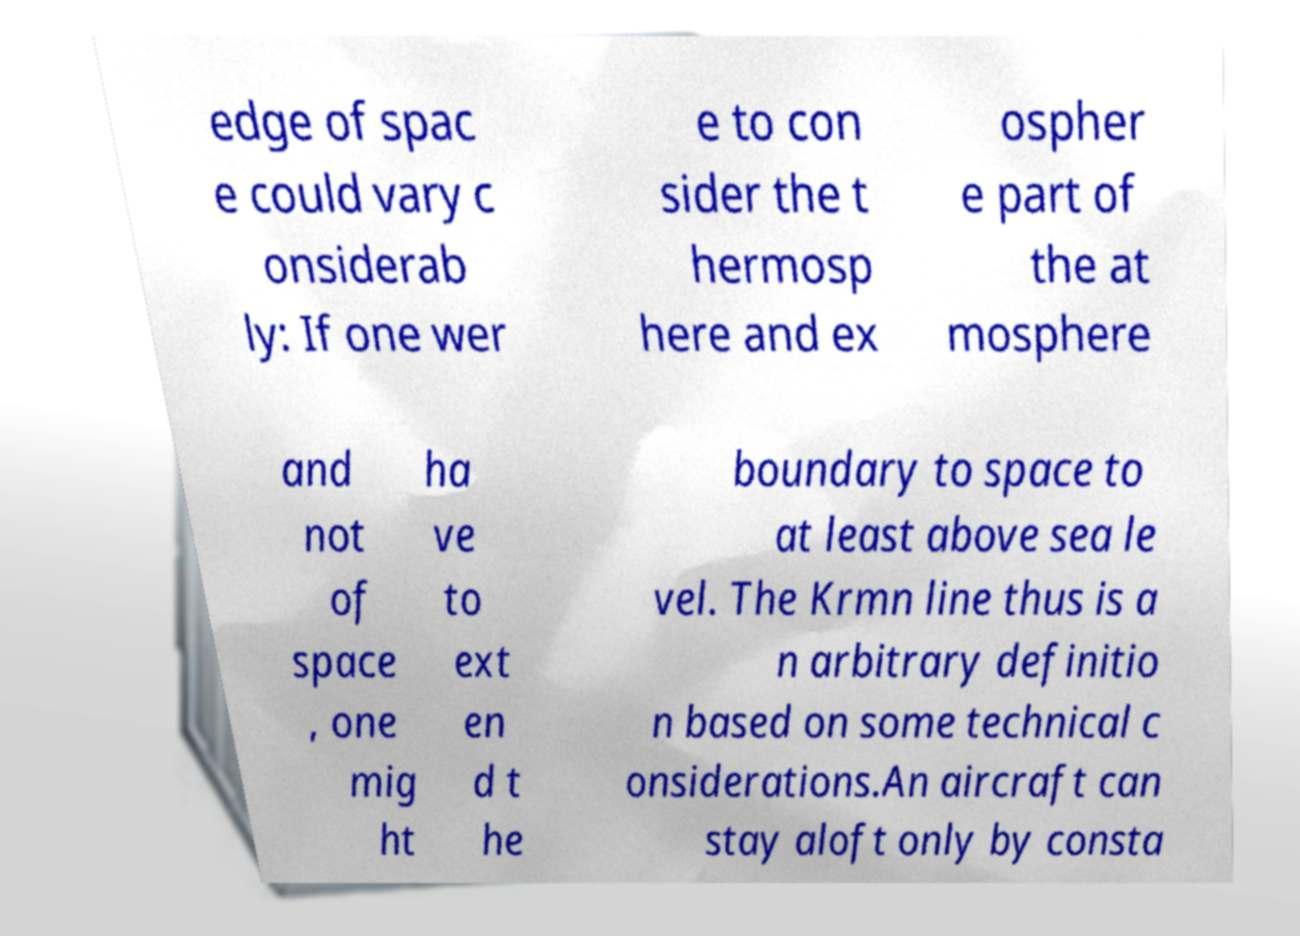Please identify and transcribe the text found in this image. edge of spac e could vary c onsiderab ly: If one wer e to con sider the t hermosp here and ex ospher e part of the at mosphere and not of space , one mig ht ha ve to ext en d t he boundary to space to at least above sea le vel. The Krmn line thus is a n arbitrary definitio n based on some technical c onsiderations.An aircraft can stay aloft only by consta 